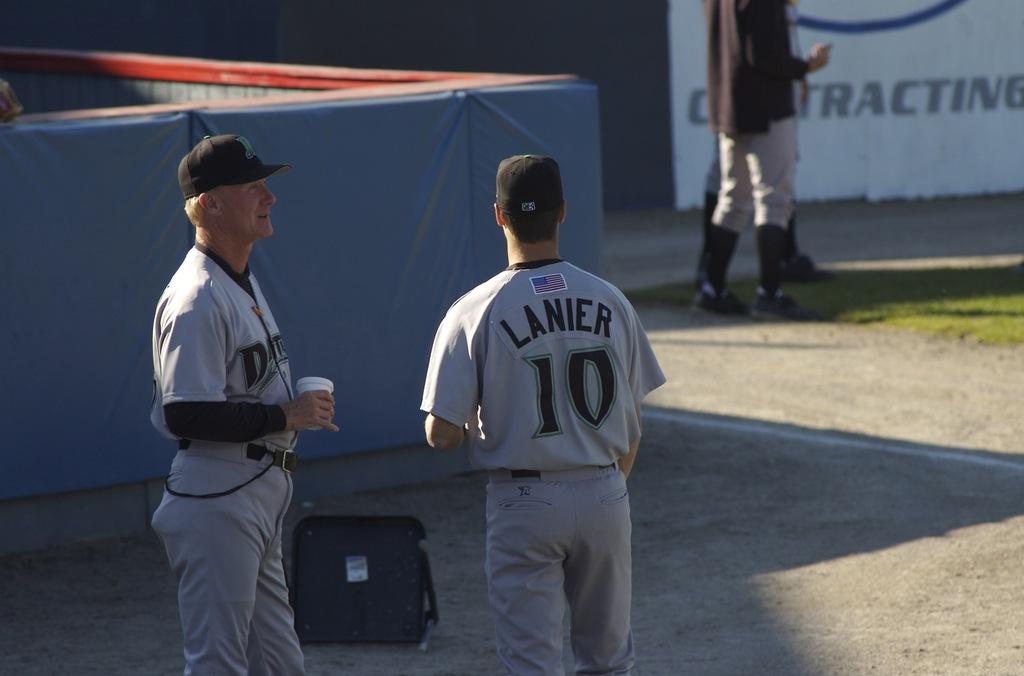What number is lanier?
Keep it short and to the point. 10. 